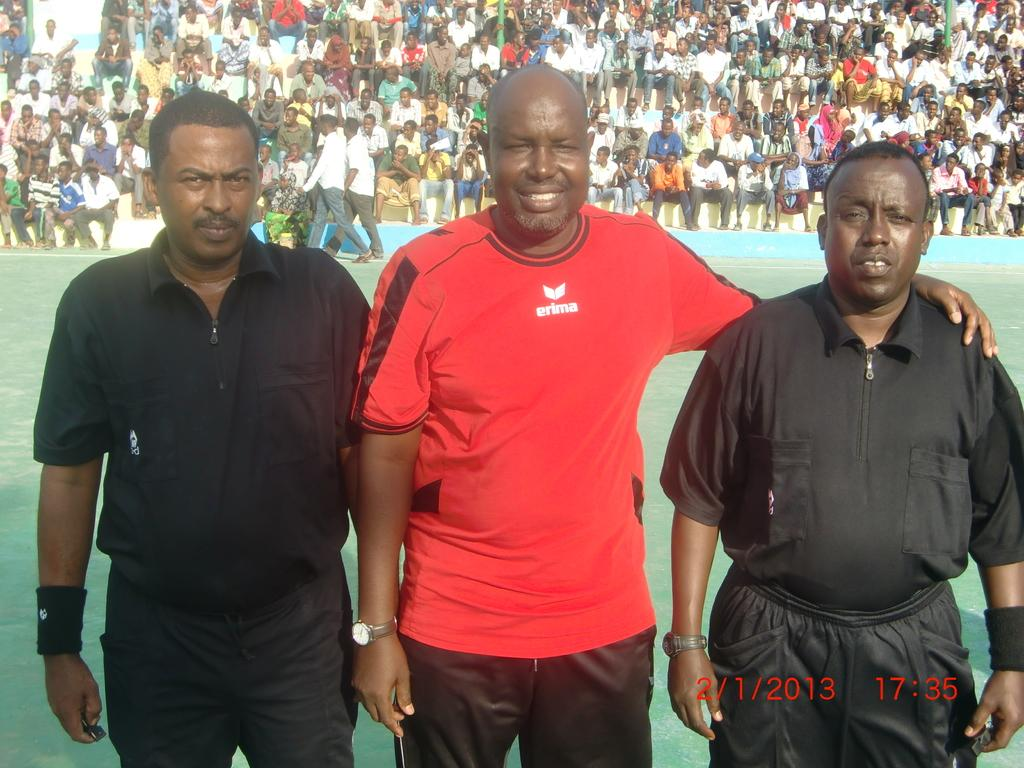What is the main subject of the image? The main subject of the image is a group of people. What are some of the people in the image doing? Some people are standing on the ground, while others are sitting. Is there any additional information about the image? Yes, there is a watermark in the bottom right corner of the image. What type of appliance can be seen in the image? There is no appliance present in the image; it features a group of people. What year is depicted in the image? The provided facts do not mention any specific year, so it cannot be determined from the image. 